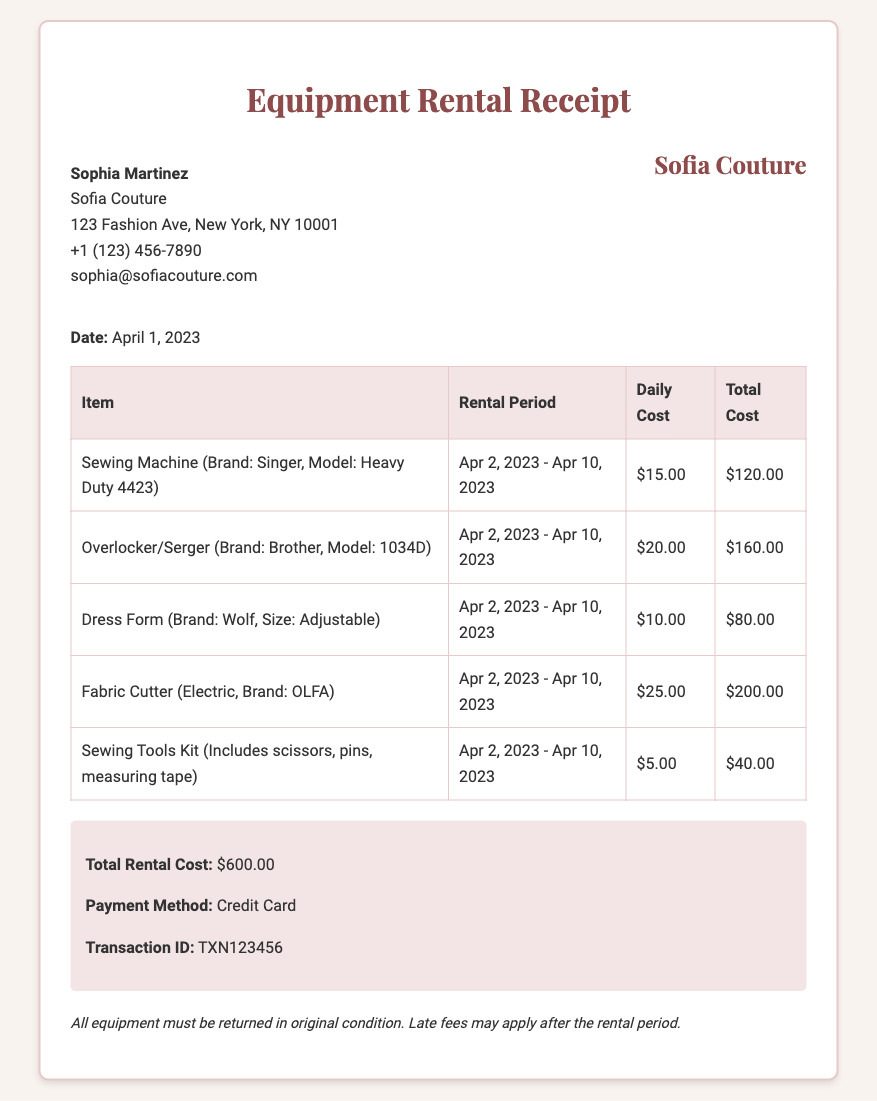What is the date of the receipt? The date is specified at the beginning of the document, showing when the transaction took place.
Answer: April 1, 2023 Who is the renter? The document includes the name of the individual or entity renting the equipment.
Answer: Sophia Martinez What is the total rental cost? The total rental cost is summarized in the document, representing the sum of all item costs.
Answer: $600.00 What type of sewing machine was rented? The specific sewing machine including its brand and model is listed in the itemized section.
Answer: Singer, Model: Heavy Duty 4423 What is the rental period for the equipment? The rental period is detailed for each item, indicating when the equipment was rented and due back.
Answer: Apr 2, 2023 - Apr 10, 2023 What is the transaction ID? The transaction ID is provided for reference and tracking of the rental transaction.
Answer: TXN123456 How many items were rented? The document lists each item being rented, allowing for a count of total items included in the rental.
Answer: 5 What is the payment method used? The document specifies how the payment was processed for the rental cost.
Answer: Credit Card What is mentioned regarding equipment return? The document contains notes about the return condition and potential fees.
Answer: All equipment must be returned in original condition 